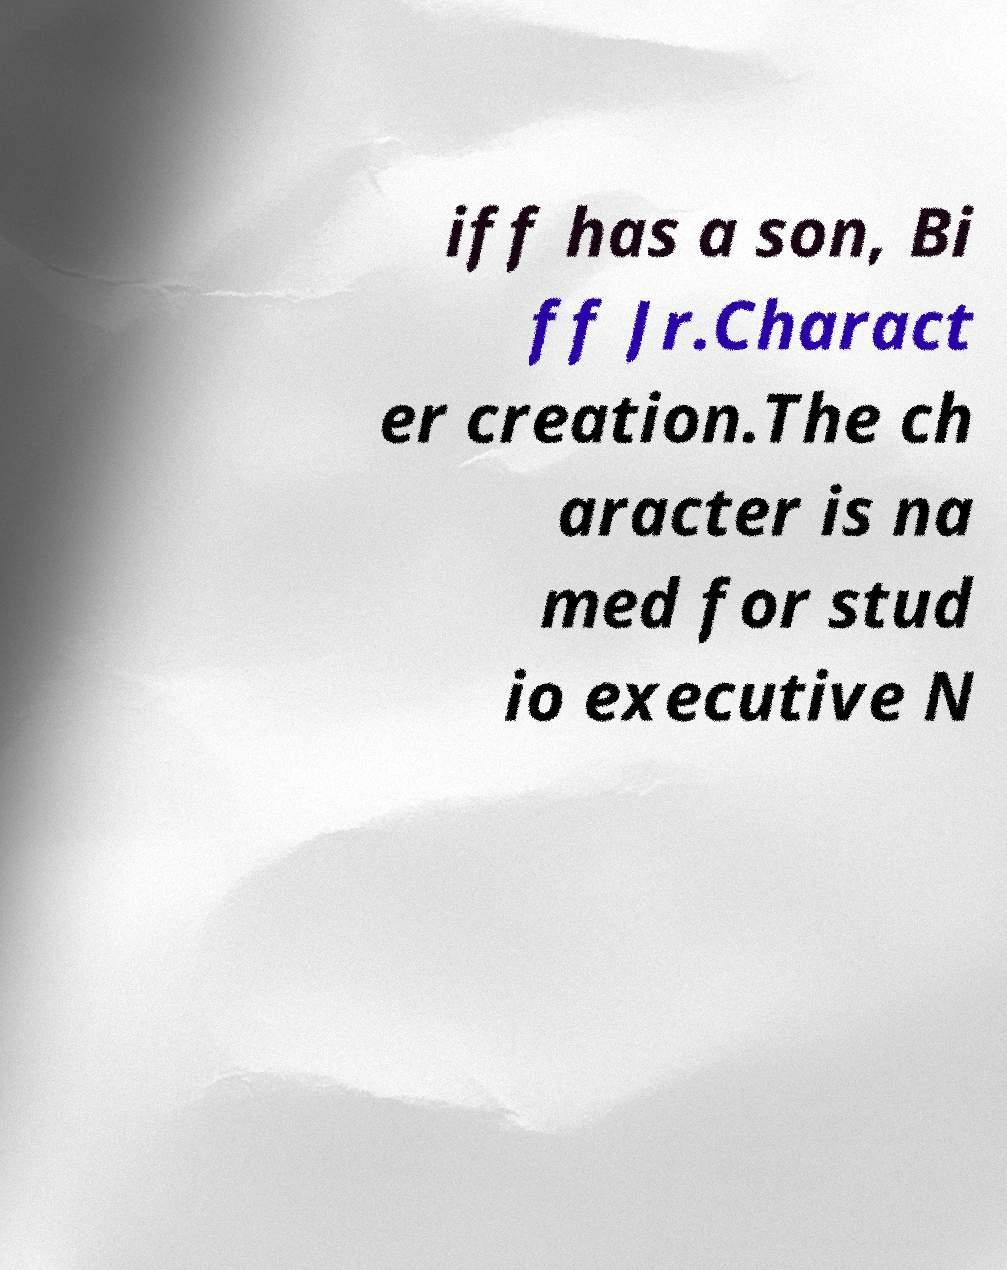I need the written content from this picture converted into text. Can you do that? iff has a son, Bi ff Jr.Charact er creation.The ch aracter is na med for stud io executive N 